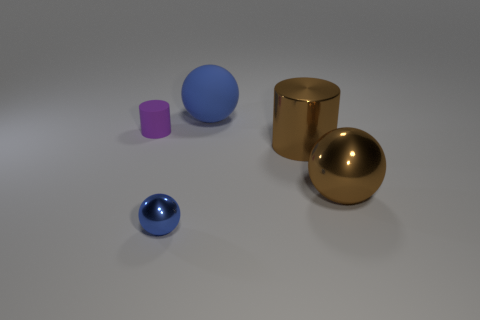There is a brown object behind the brown sphere; does it have the same shape as the tiny metallic thing?
Your response must be concise. No. Are there more purple objects that are on the right side of the tiny metallic sphere than tiny blue objects?
Keep it short and to the point. No. What number of objects are on the left side of the big brown sphere and in front of the large blue matte object?
Offer a very short reply. 3. What color is the big shiny thing that is behind the shiny sphere right of the big rubber thing?
Your response must be concise. Brown. What number of large metal cylinders are the same color as the small sphere?
Your answer should be compact. 0. Does the matte ball have the same color as the shiny object to the left of the shiny cylinder?
Keep it short and to the point. Yes. Is the number of gray objects less than the number of small purple rubber cylinders?
Your answer should be compact. Yes. Is the number of tiny blue shiny balls behind the large brown cylinder greater than the number of purple matte objects that are right of the big blue matte sphere?
Keep it short and to the point. No. Does the brown sphere have the same material as the tiny ball?
Keep it short and to the point. Yes. How many objects are left of the tiny thing that is behind the tiny blue metal object?
Provide a succinct answer. 0. 